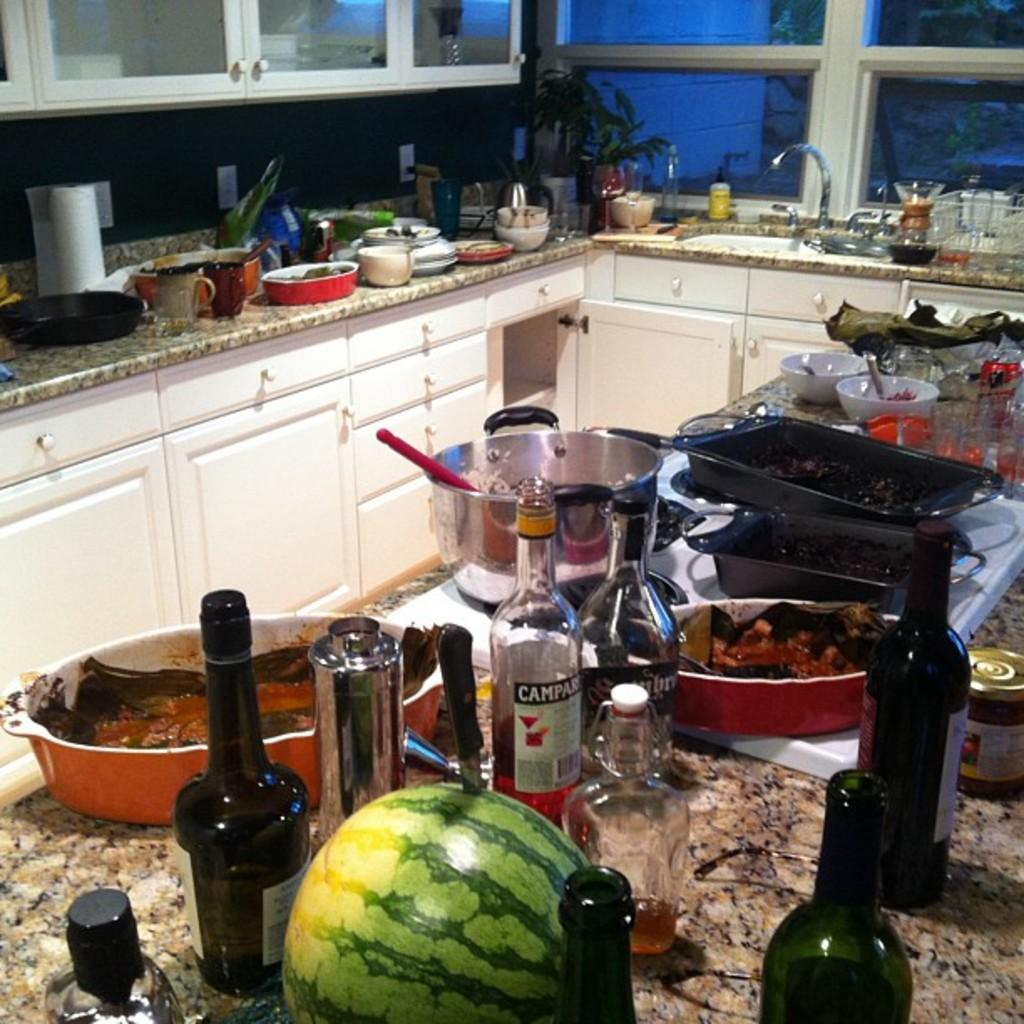What type of room is depicted in the image? The image depicts a kitchen. What type of storage furniture is present in the kitchen? There are cupboards in the kitchen. What type of surface is present in the kitchen for eating or working? There is a table in the kitchen. What items can be seen on the table in the image? A bottle, a watermelon, a pan, trays, bowls, and glasses are on the table in the image. What type of window is present in the kitchen? There is a window in the kitchen. What type of fixture is present for water access in the kitchen? There is a tap in the kitchen. What type of jail is visible in the image? There is no jail present in the image; it depicts a kitchen. How does the kitchen express hate towards any particular food item? The image does not express any emotions or preferences towards food items; it simply shows a kitchen with various items on the table. 